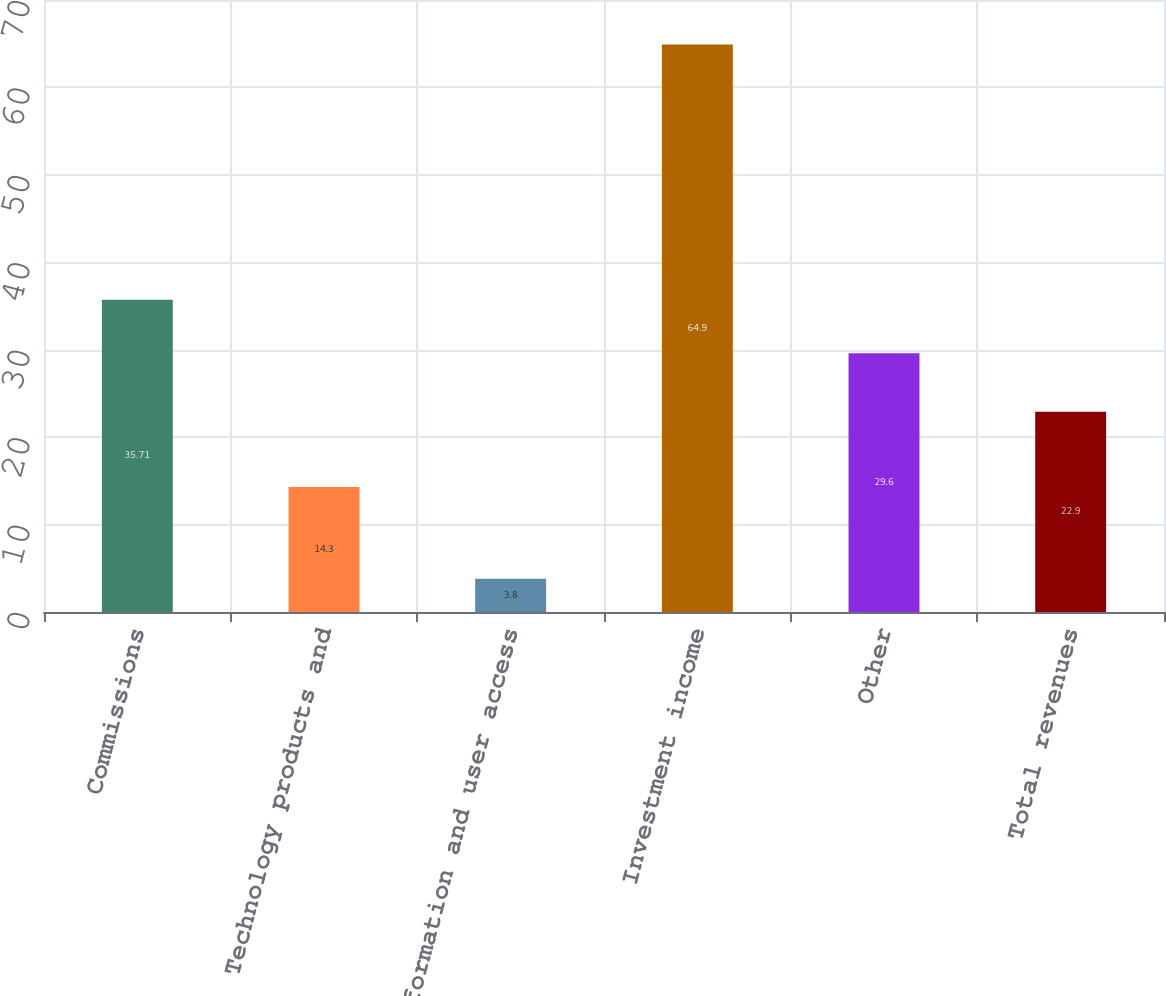Convert chart to OTSL. <chart><loc_0><loc_0><loc_500><loc_500><bar_chart><fcel>Commissions<fcel>Technology products and<fcel>Information and user access<fcel>Investment income<fcel>Other<fcel>Total revenues<nl><fcel>35.71<fcel>14.3<fcel>3.8<fcel>64.9<fcel>29.6<fcel>22.9<nl></chart> 